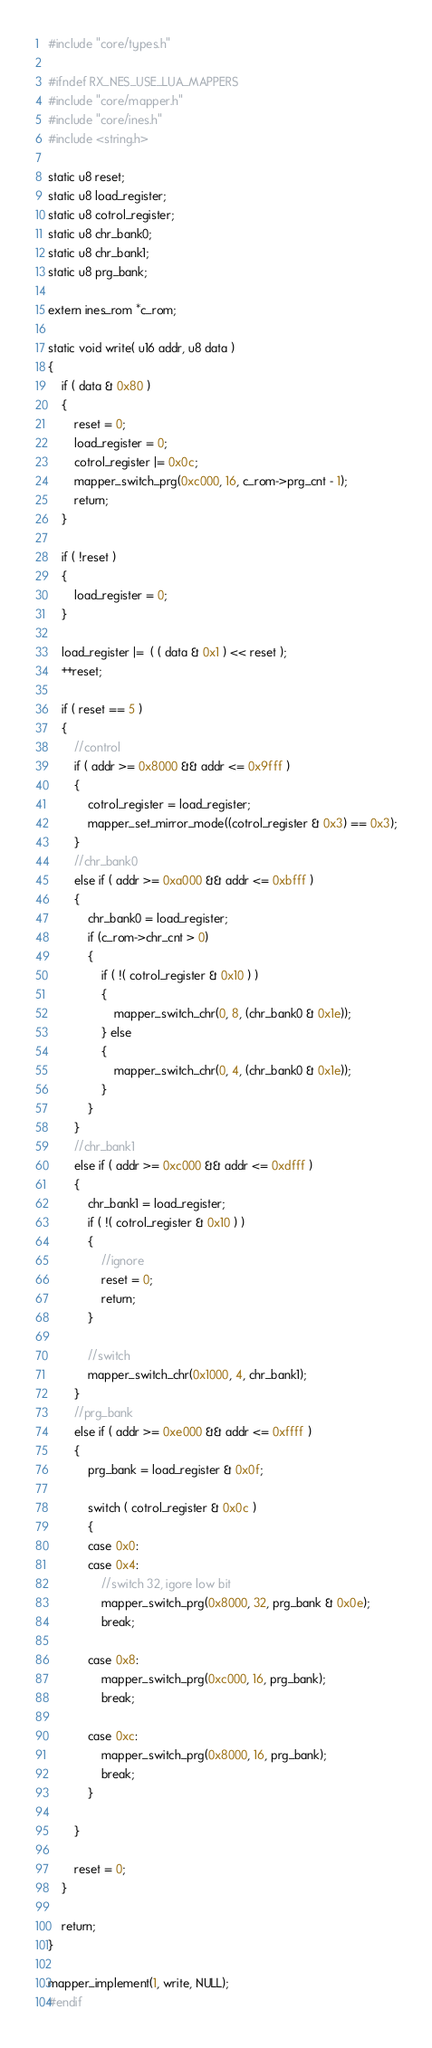<code> <loc_0><loc_0><loc_500><loc_500><_C_>#include "core/types.h"

#ifndef RX_NES_USE_LUA_MAPPERS
#include "core/mapper.h"
#include "core/ines.h"
#include <string.h>

static u8 reset;
static u8 load_register;
static u8 cotrol_register;
static u8 chr_bank0;
static u8 chr_bank1;
static u8 prg_bank;

extern ines_rom *c_rom;

static void write( u16 addr, u8 data )
{
    if ( data & 0x80 )
    {
        reset = 0;
        load_register = 0;
        cotrol_register |= 0x0c;
		mapper_switch_prg(0xc000, 16, c_rom->prg_cnt - 1);
        return;
    }

    if ( !reset )
    {
        load_register = 0;
    }

    load_register |=  ( ( data & 0x1 ) << reset );
    ++reset;

    if ( reset == 5 )
    {
        //control
        if ( addr >= 0x8000 && addr <= 0x9fff )
        {
            cotrol_register = load_register;
			mapper_set_mirror_mode((cotrol_register & 0x3) == 0x3);
        }
        //chr_bank0
        else if ( addr >= 0xa000 && addr <= 0xbfff )
        {
            chr_bank0 = load_register;
			if (c_rom->chr_cnt > 0)
			{
				if ( !( cotrol_register & 0x10 ) )
				{
					mapper_switch_chr(0, 8, (chr_bank0 & 0x1e));
				} else
				{
					mapper_switch_chr(0, 4, (chr_bank0 & 0x1e));
				}
			}
        }
        //chr_bank1
        else if ( addr >= 0xc000 && addr <= 0xdfff )
        {
            chr_bank1 = load_register;
            if ( !( cotrol_register & 0x10 ) )
            {
                //ignore
                reset = 0;
                return;
            }

            //switch
			mapper_switch_chr(0x1000, 4, chr_bank1);
        }
        //prg_bank
        else if ( addr >= 0xe000 && addr <= 0xffff )
        {
            prg_bank = load_register & 0x0f;

            switch ( cotrol_register & 0x0c )
            {
            case 0x0:
            case 0x4:
                //switch 32, igore low bit
				mapper_switch_prg(0x8000, 32, prg_bank & 0x0e);
                break;

            case 0x8:
				mapper_switch_prg(0xc000, 16, prg_bank);
                break;

            case 0xc:
				mapper_switch_prg(0x8000, 16, prg_bank);
                break;
            }

        }

        reset = 0;
    }

    return;
}

mapper_implement(1, write, NULL);
#endif</code> 